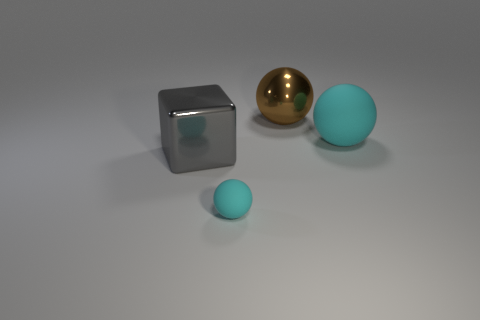Do the rubber object that is in front of the large metallic block and the cyan rubber thing behind the large gray metallic block have the same shape?
Offer a terse response. Yes. Is the number of cyan rubber balls that are to the right of the brown thing the same as the number of large blue rubber things?
Ensure brevity in your answer.  No. There is another big object that is the same shape as the big brown thing; what is it made of?
Ensure brevity in your answer.  Rubber. What is the shape of the cyan object that is in front of the big metal thing in front of the big cyan rubber ball?
Your answer should be very brief. Sphere. Does the large brown thing behind the gray metallic cube have the same material as the gray thing?
Your answer should be very brief. Yes. Is the number of shiny spheres right of the large cyan thing the same as the number of large objects to the right of the big brown metal thing?
Your response must be concise. No. What material is the big thing that is the same color as the tiny rubber ball?
Your answer should be very brief. Rubber. There is a metallic object that is on the right side of the large block; how many large cyan rubber things are left of it?
Your response must be concise. 0. There is a sphere in front of the big cyan ball; is it the same color as the large object on the right side of the large brown metal thing?
Give a very brief answer. Yes. What is the material of the sphere that is the same size as the brown shiny thing?
Offer a very short reply. Rubber. 